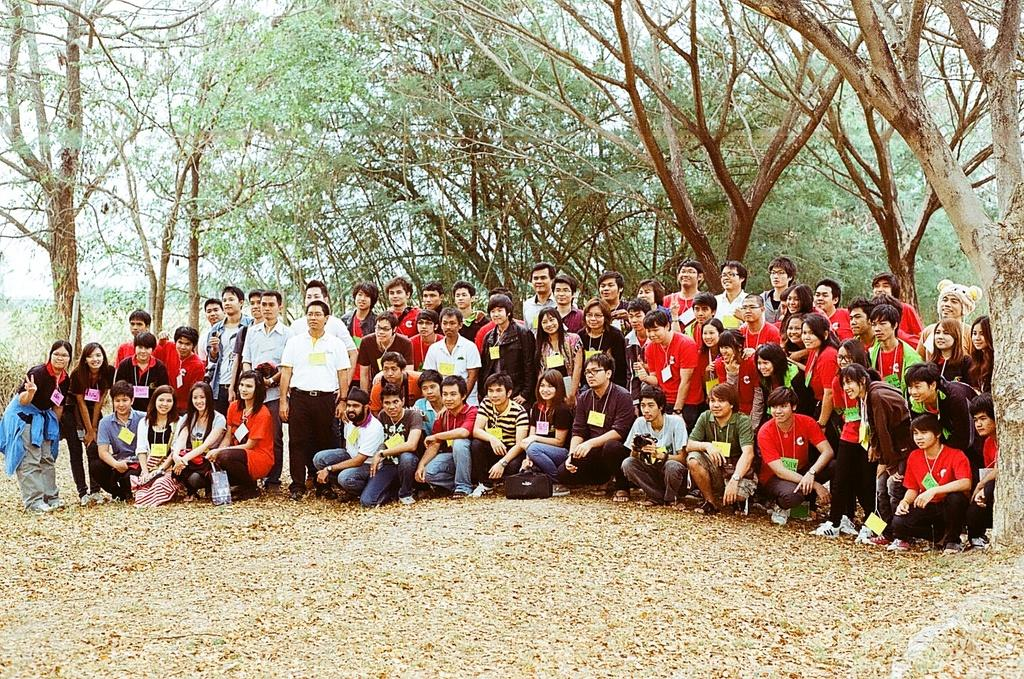What are the people in the image doing? There are people standing and people in a squat position in the image. What can be seen in the background of the image? There are trees visible in the background of the image. What type of road can be seen in the image? There is no road visible in the image; it features people standing and squatting with trees in the background. 